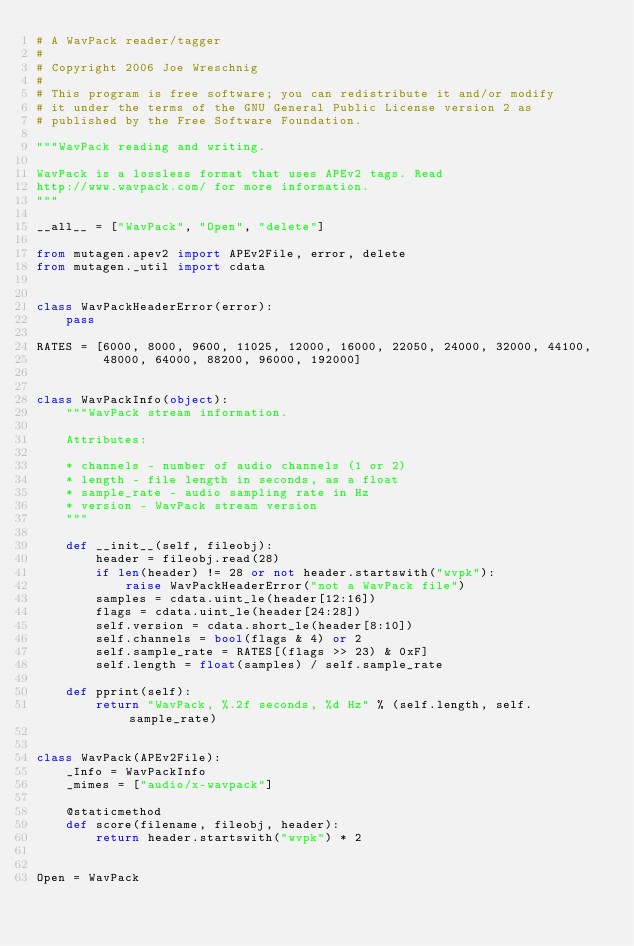<code> <loc_0><loc_0><loc_500><loc_500><_Python_># A WavPack reader/tagger
#
# Copyright 2006 Joe Wreschnig
#
# This program is free software; you can redistribute it and/or modify
# it under the terms of the GNU General Public License version 2 as
# published by the Free Software Foundation.

"""WavPack reading and writing.

WavPack is a lossless format that uses APEv2 tags. Read
http://www.wavpack.com/ for more information.
"""

__all__ = ["WavPack", "Open", "delete"]

from mutagen.apev2 import APEv2File, error, delete
from mutagen._util import cdata


class WavPackHeaderError(error):
    pass

RATES = [6000, 8000, 9600, 11025, 12000, 16000, 22050, 24000, 32000, 44100,
         48000, 64000, 88200, 96000, 192000]


class WavPackInfo(object):
    """WavPack stream information.

    Attributes:

    * channels - number of audio channels (1 or 2)
    * length - file length in seconds, as a float
    * sample_rate - audio sampling rate in Hz
    * version - WavPack stream version
    """

    def __init__(self, fileobj):
        header = fileobj.read(28)
        if len(header) != 28 or not header.startswith("wvpk"):
            raise WavPackHeaderError("not a WavPack file")
        samples = cdata.uint_le(header[12:16])
        flags = cdata.uint_le(header[24:28])
        self.version = cdata.short_le(header[8:10])
        self.channels = bool(flags & 4) or 2
        self.sample_rate = RATES[(flags >> 23) & 0xF]
        self.length = float(samples) / self.sample_rate

    def pprint(self):
        return "WavPack, %.2f seconds, %d Hz" % (self.length, self.sample_rate)


class WavPack(APEv2File):
    _Info = WavPackInfo
    _mimes = ["audio/x-wavpack"]

    @staticmethod
    def score(filename, fileobj, header):
        return header.startswith("wvpk") * 2


Open = WavPack
</code> 